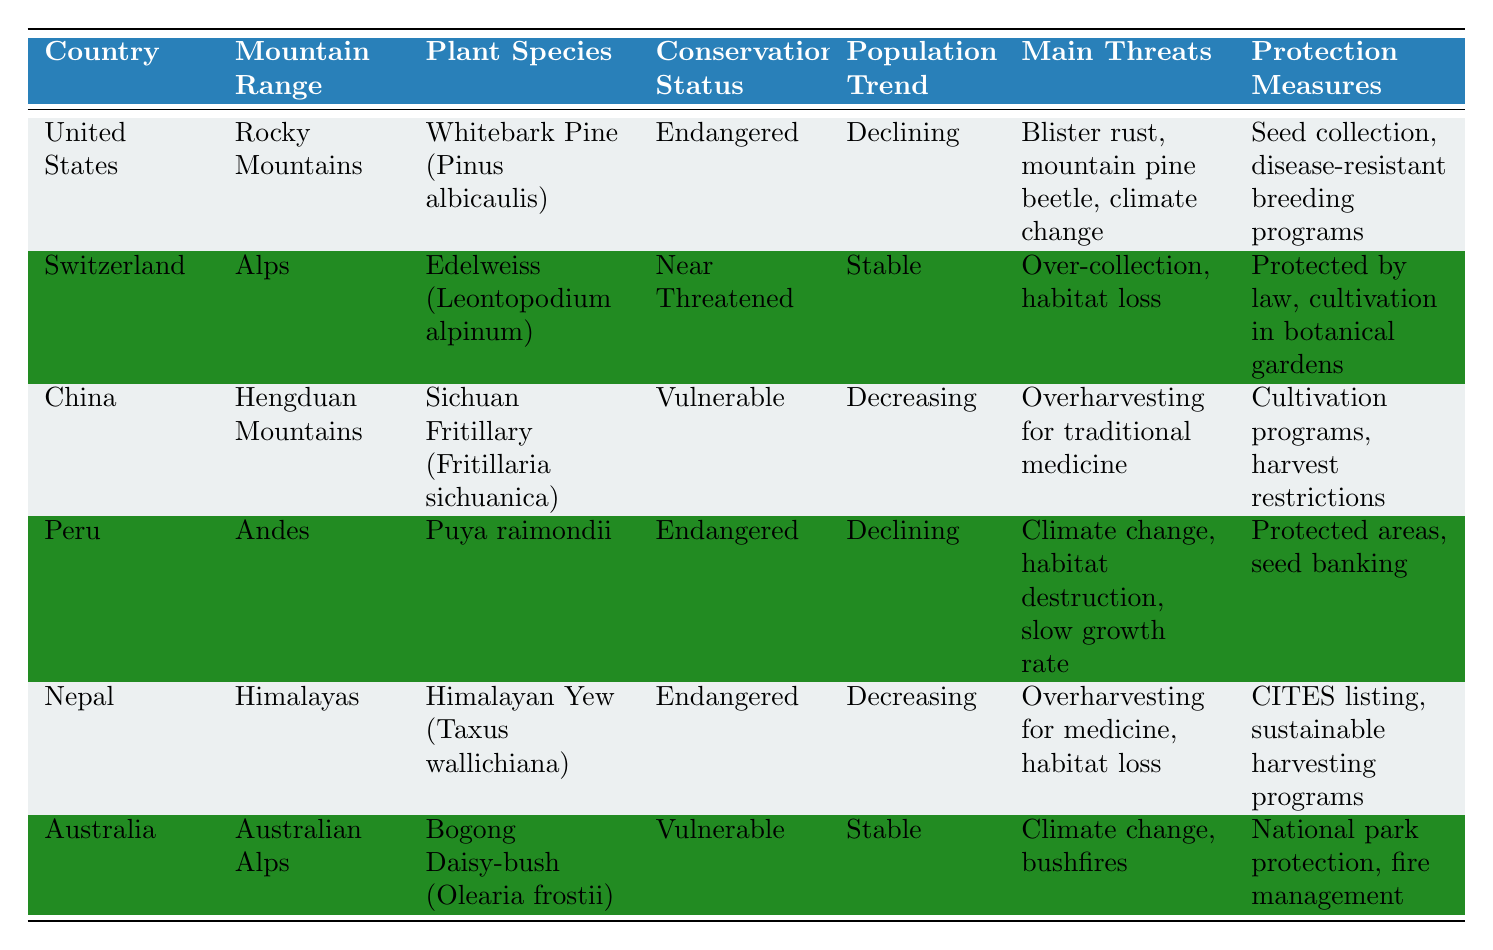What is the conservation status of the Whitebark Pine in the United States? The table shows that the conservation status of the Whitebark Pine (Pinus albicaulis) in the United States is categorized as "Endangered."
Answer: Endangered Which plant species has a "Stable" population trend in the Alps? Referring to the table, it indicates that the Edelweiss (Leontopodium alpinum) in Switzerland's Alps has a population trend described as "Stable."
Answer: Edelweiss (Leontopodium alpinum) How many of the listed plant species have an "Endangered" conservation status? The data shows three plant species with an "Endangered" status: Whitebark Pine, Puya raimondii, and Himalayan Yew. Therefore, the total count is 3.
Answer: 3 Is the Sichuan Fritillary's population trend increasing? The table states that the population trend of the Sichuan Fritillary is "Decreasing," which means it is not increasing. Therefore, the answer is no.
Answer: No Which country is protecting its rare plants through cultivation programs and harvest restrictions? In the table, it is noted that China protects the Sichuan Fritillary (Fritillaria sichuanica) through cultivation programs and harvest restrictions.
Answer: China What is the main threat to the Puya raimondii species in Peru? According to the table, the main threats to Puya raimondii in Peru include climate change, habitat destruction, and slow growth rate.
Answer: Climate change, habitat destruction, slow growth rate Which mountain range has a rare plant that is protected by law and is cultivated in botanical gardens? The table indicates that the Alps in Switzerland have the Edelweiss (Leontopodium alpinum), which is protected by law and cultivated in botanical gardens.
Answer: Alps What is the difference in conservation status between the Himalayan Yew and the Bogong Daisy-bush? The Himalayan Yew is categorized as "Endangered," while the Bogong Daisy-bush is "Vulnerable." The difference in their conservation statuses is one category - Endangered is worse than Vulnerable.
Answer: One category How many countries have plant species that are classified as "Vulnerable"? The table identifies that there are two countries with plant species classified as "Vulnerable": China (Sichuan Fritillary) and Australia (Bogong Daisy-bush). Hence the total count is 2.
Answer: 2 